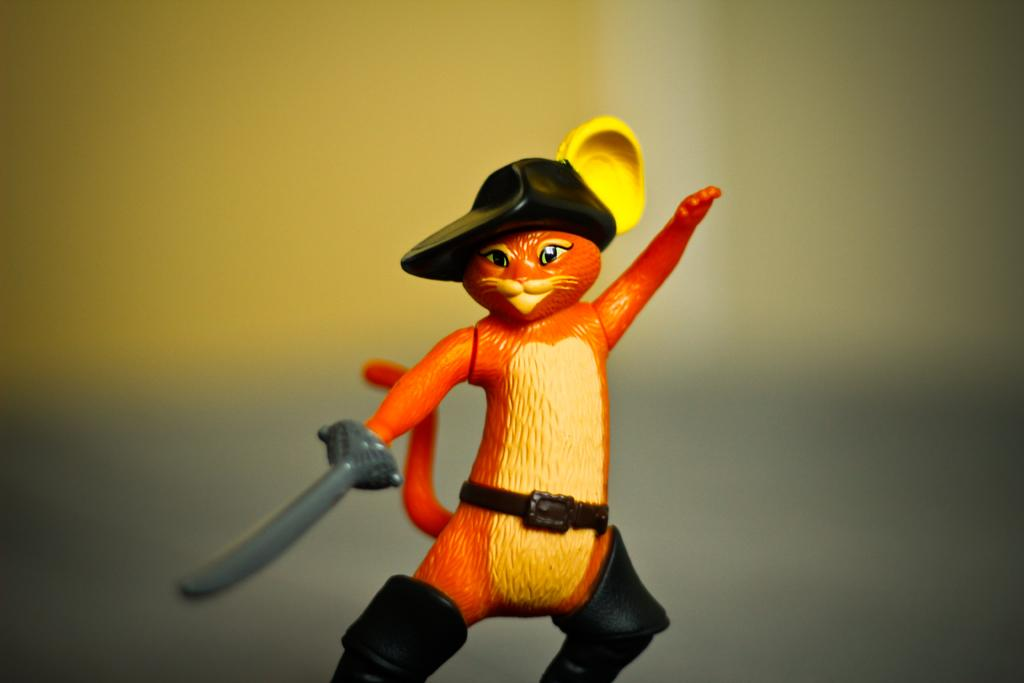What is the main subject of the image? The main subject of the image is a toy cat. How is the background of the image depicted? The background of the image is blurred. What is the income of the toy cat in the image? There is no information about the toy cat's income in the image, as it is an inanimate object and does not have an income. 